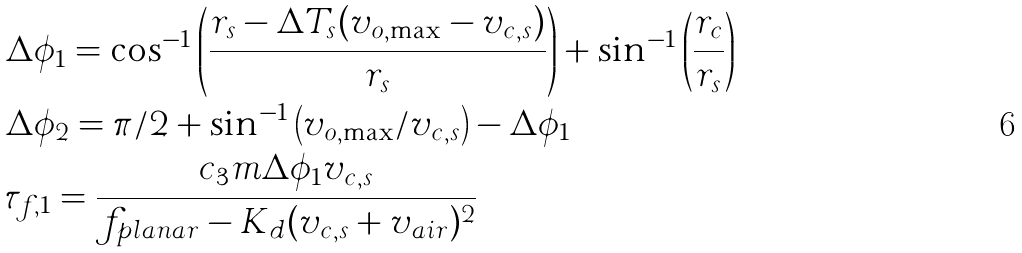Convert formula to latex. <formula><loc_0><loc_0><loc_500><loc_500>& \Delta \phi _ { 1 } = \cos ^ { - 1 } \left ( \frac { r _ { s } - \Delta T _ { s } ( v _ { o , \max } - v _ { c , s } ) } { r _ { s } } \right ) + \sin ^ { - 1 } \left ( \frac { r _ { c } } { r _ { s } } \right ) \\ & \Delta \phi _ { 2 } = \pi / 2 + \sin ^ { - 1 } \left ( v _ { o , \max } / v _ { c , s } \right ) - \Delta \phi _ { 1 } \\ & \tau _ { f , 1 } = \frac { c _ { 3 } m \Delta \phi _ { 1 } v _ { c , s } } { f _ { p l a n a r } - K _ { d } ( v _ { c , s } + v _ { a i r } ) ^ { 2 } }</formula> 